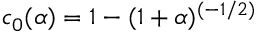<formula> <loc_0><loc_0><loc_500><loc_500>c _ { 0 } ( \alpha ) = 1 - ( 1 + \alpha ) ^ { ( - 1 / 2 ) }</formula> 